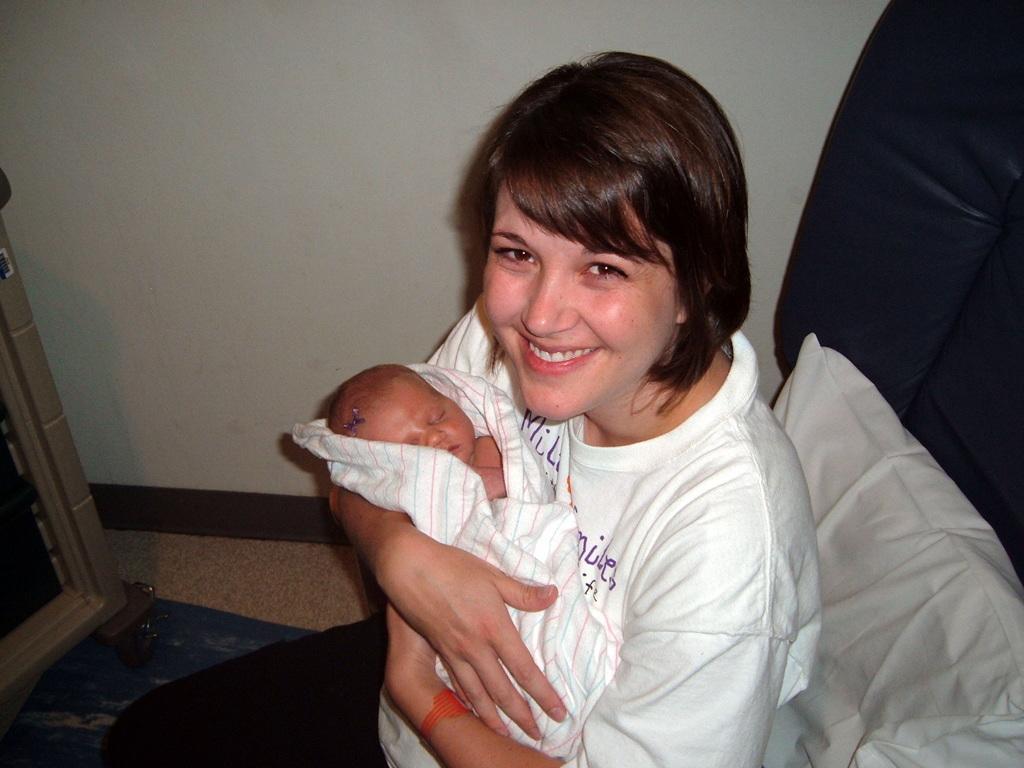How would you summarize this image in a sentence or two? In this image, we can see a person sitting on the chair and holding a baby with her hands. There is a wooden frame on the left side of the image. In the background of the image, there is a wall. 